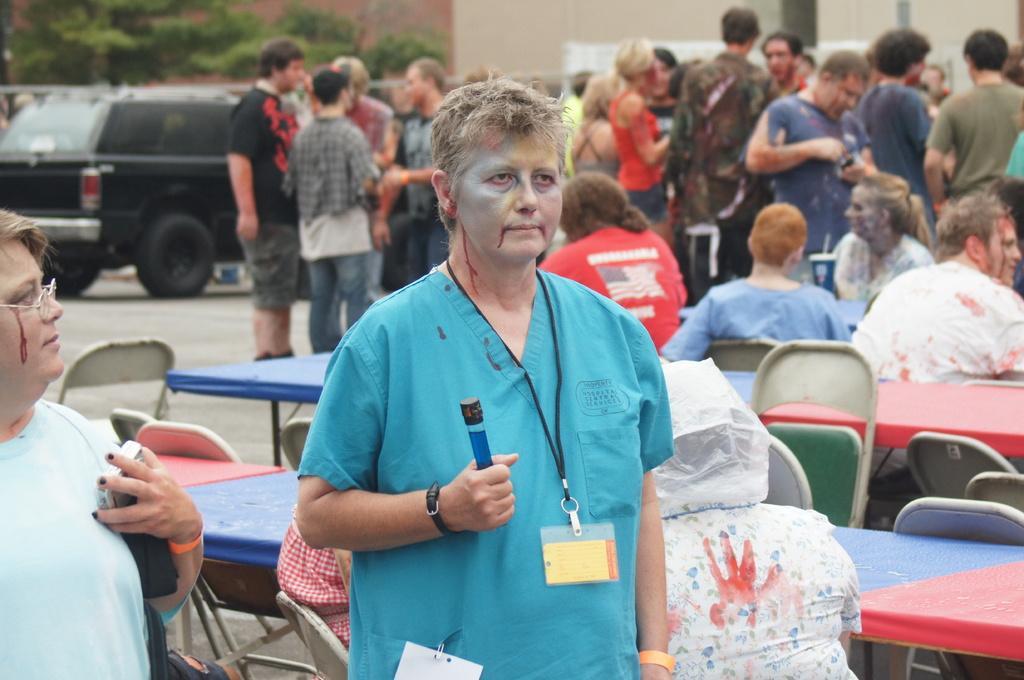Could you give a brief overview of what you see in this image? This is the picture of a place where we have a person who is holding something in the hand and to the side there is an other person and also we can see some people, trees, car, chairs and tables behind. 